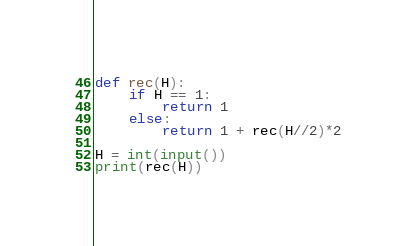<code> <loc_0><loc_0><loc_500><loc_500><_Python_>def rec(H):
    if H == 1:
        return 1
    else:
        return 1 + rec(H//2)*2

H = int(input())
print(rec(H))</code> 